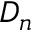Convert formula to latex. <formula><loc_0><loc_0><loc_500><loc_500>D _ { n }</formula> 